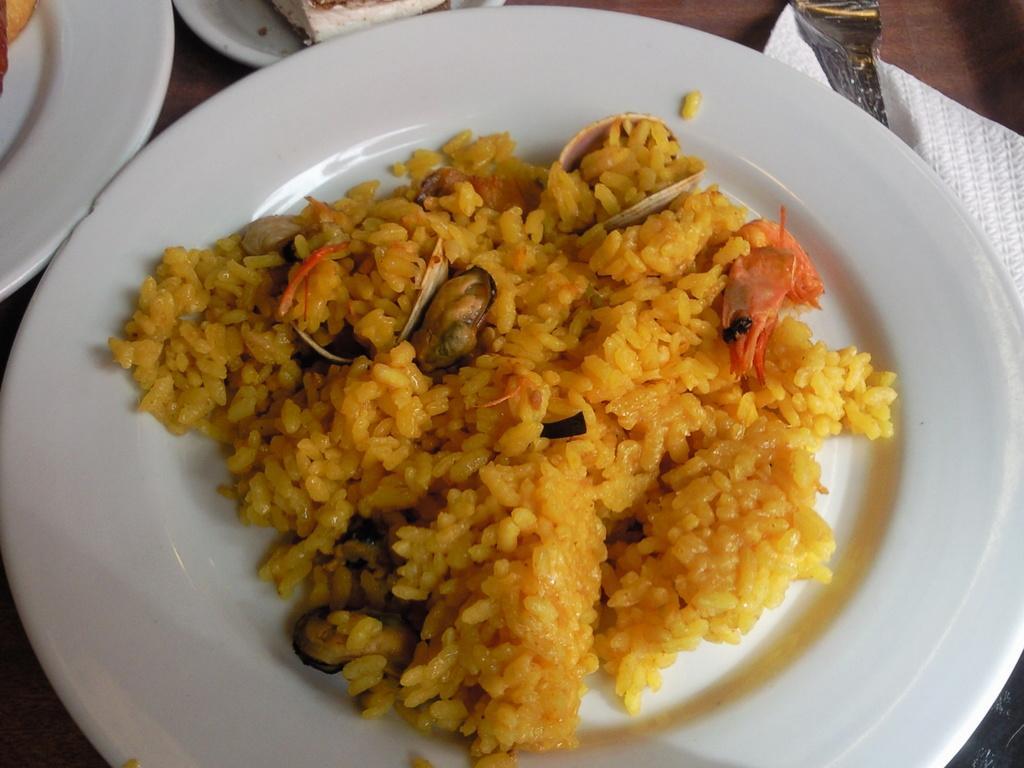In one or two sentences, can you explain what this image depicts? This is a zoomed in picture. In the center there is a white color palette containing rice and some food items and the platter is on the top of the wooden table. In the background we can see some other white color platters containing food and we can see the tissue paper. 